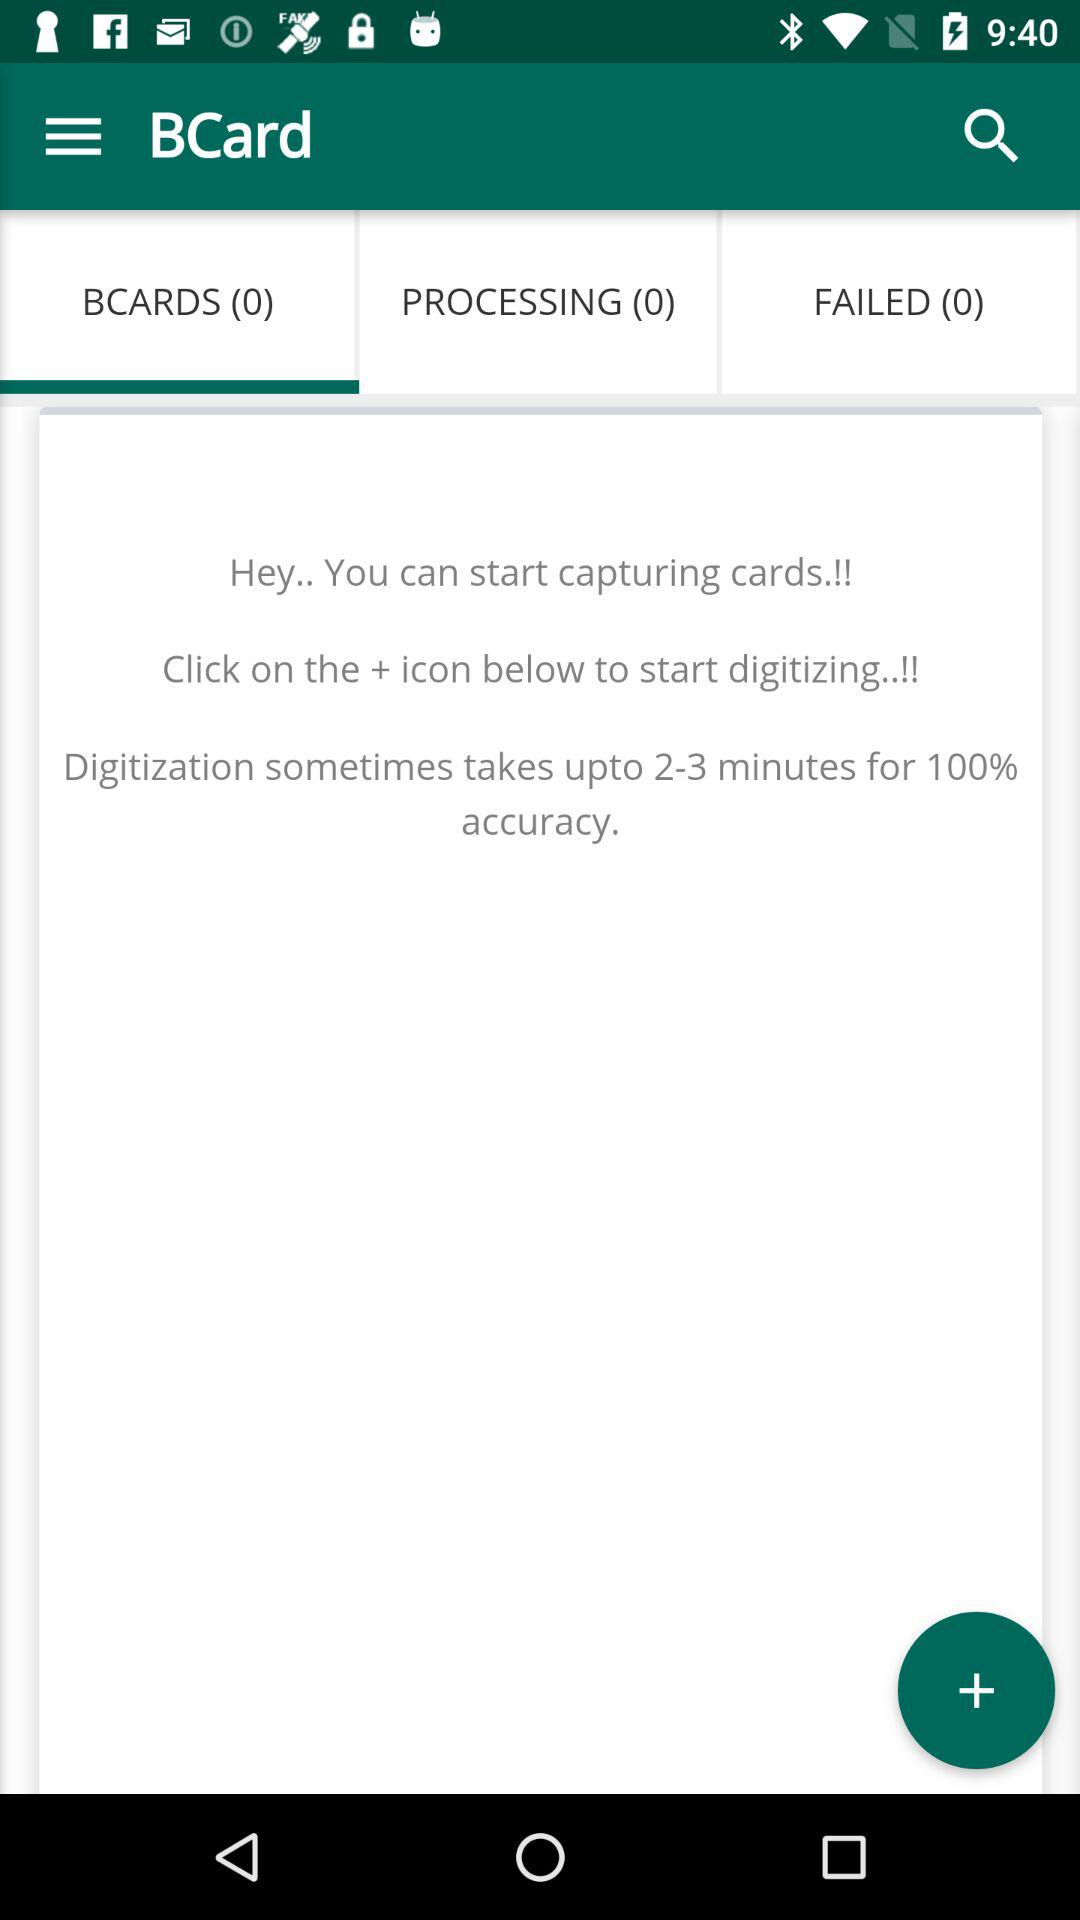How many minutes will digitization take for 100% accuracy? Digitization will take up to 2 to 3 minutes for 100% accuracy. 